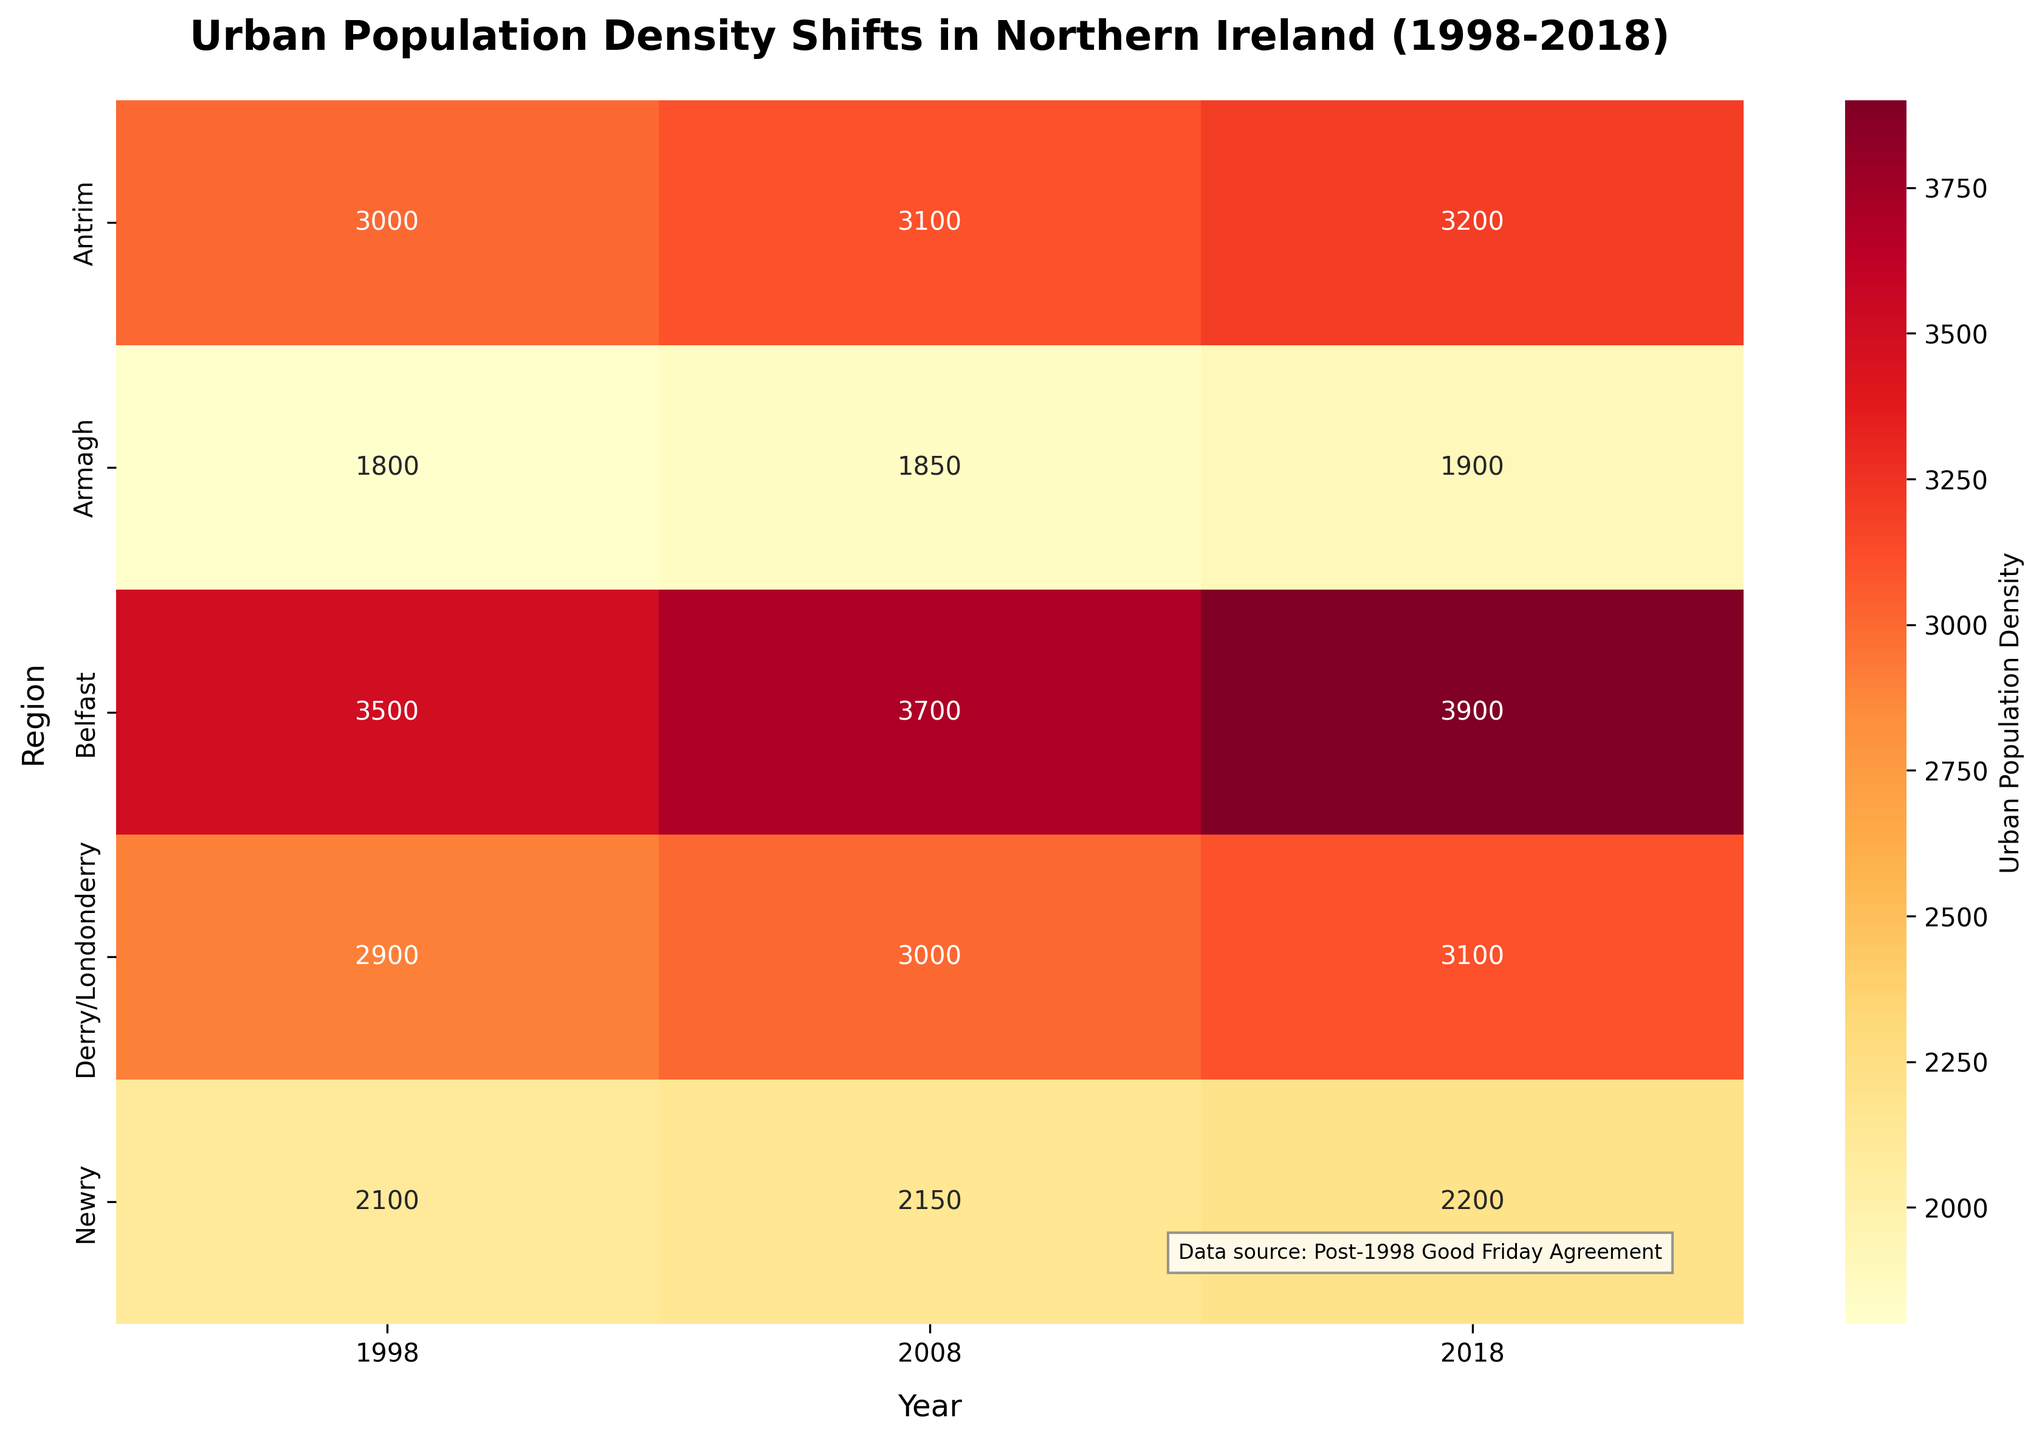What is the title of the heatmap? The title is usually located at the top of the heatmap and gives an overview of what the visualization is about. By looking at the heatmap, we can see the text that describes it.
Answer: Urban Population Density Shifts in Northern Ireland (1998-2018) What is the urban population density of Belfast in 2018? To find this information, locate the row for Belfast and the column for 2018, then read the value from the heatmap.
Answer: 3900 Which region had the lowest urban population density in 1998? First, identify all the urban population density values for 1998 along the respective column. Then, find the smallest value and note the corresponding region.
Answer: Armagh What is the average urban population density across all regions in 2008? Identify all the urban population density values for 2008, sum them up, and then divide by the number of regions to calculate the average. The values are 3700, 3000, 2150, 1850, and 3100. (3700+3000+2150+1850+3100) / 5 = 13800 / 5 = 2760.
Answer: 2760 Which ethnic group in Belfast has the highest urban population density in 2018 compared to 1998? In Belfast, compare the values for 2018 and 1998 for the groups present. The urban population density for 1998 is 3500 and for 2018 is 3900. The large increase is for the Irish ethnic group.
Answer: Irish How does the urban population density of Derry/Londonderry in 2008 compare to 1998 and 2018? Locate the values for Derry/Londonderry for the years 1998, 2008, and 2018. Compare these values to understand the trends. The values are 2900 in 1998, 3000 in 2008, and 3100 in 2018.
Answer: It increased, from 2900 to 3000 to 3100 What is the total increase in urban population density for Antrim from 1998 to 2018? Find the urban population density values for Antrim in 1998 and 2018, then calculate the difference between the two. The values are 3000 and 3200 respectively, so the increase is 3200 - 3000.
Answer: 200 Which region shows the smallest change in urban population density between 1998 and 2018? Calculate the difference in urban population density for each region between 1998 and 2018, and then identify the smallest change. Values are:
Belfast: 3900 - 3500 = 400
Derry/Londonderry: 3100 - 2900 = 200
Newry: 2200 - 2100 = 100
Armagh: 1900 - 1800 = 100
Antrim: 3200 - 3000 = 200
The smallest change is shared by Newry and Armagh, both with 100.
Answer: Newry and Armagh Identify the region and ethnic group with the highest urban population density in 2008. Locate the maximum value in the 2008 column and identify the region and ethnic group associated with it. The highest value is 3700, in Belfast with the Irish ethnic group.
Answer: Belfast, Irish How did the urban population density in Armagh change from 1998 to 2008 and then to 2018? Look at the values for Armagh across the years 1998, 2008, and 2018. The values are 1800, 1850, and 1900 respectively. Note the changes between each period: from 1800 to 1850, and then from 1850 to 1900.
Answer: It increased from 1800 to 1850 to 1900 